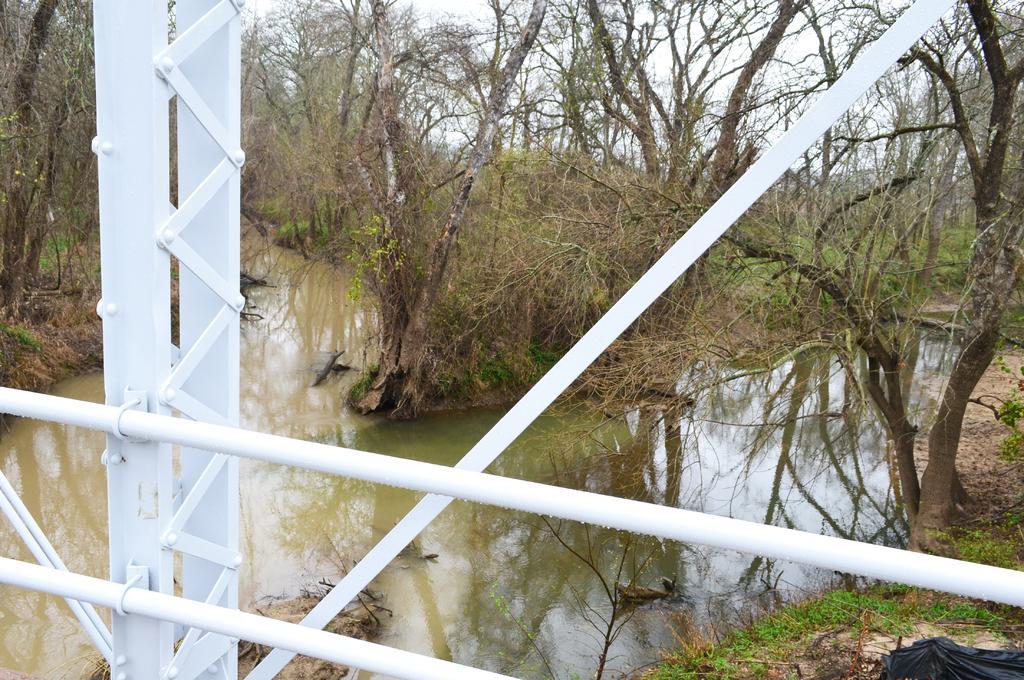Could you give a brief overview of what you see in this image? In the foreground of this image, we can see white railing of a bridge and in the background, there is a river flowing down to the bridge, trees and the sky. 